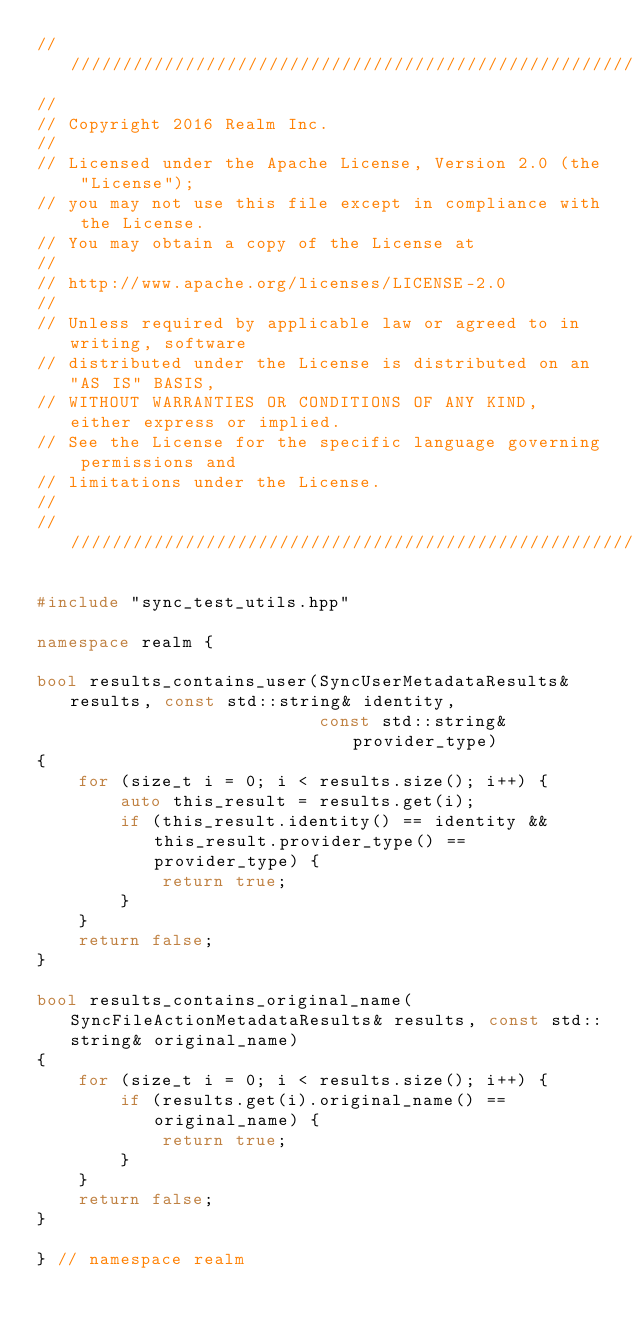Convert code to text. <code><loc_0><loc_0><loc_500><loc_500><_C++_>////////////////////////////////////////////////////////////////////////////
//
// Copyright 2016 Realm Inc.
//
// Licensed under the Apache License, Version 2.0 (the "License");
// you may not use this file except in compliance with the License.
// You may obtain a copy of the License at
//
// http://www.apache.org/licenses/LICENSE-2.0
//
// Unless required by applicable law or agreed to in writing, software
// distributed under the License is distributed on an "AS IS" BASIS,
// WITHOUT WARRANTIES OR CONDITIONS OF ANY KIND, either express or implied.
// See the License for the specific language governing permissions and
// limitations under the License.
//
////////////////////////////////////////////////////////////////////////////

#include "sync_test_utils.hpp"

namespace realm {

bool results_contains_user(SyncUserMetadataResults& results, const std::string& identity,
                           const std::string& provider_type)
{
    for (size_t i = 0; i < results.size(); i++) {
        auto this_result = results.get(i);
        if (this_result.identity() == identity && this_result.provider_type() == provider_type) {
            return true;
        }
    }
    return false;
}

bool results_contains_original_name(SyncFileActionMetadataResults& results, const std::string& original_name)
{
    for (size_t i = 0; i < results.size(); i++) {
        if (results.get(i).original_name() == original_name) {
            return true;
        }
    }
    return false;
}

} // namespace realm
</code> 